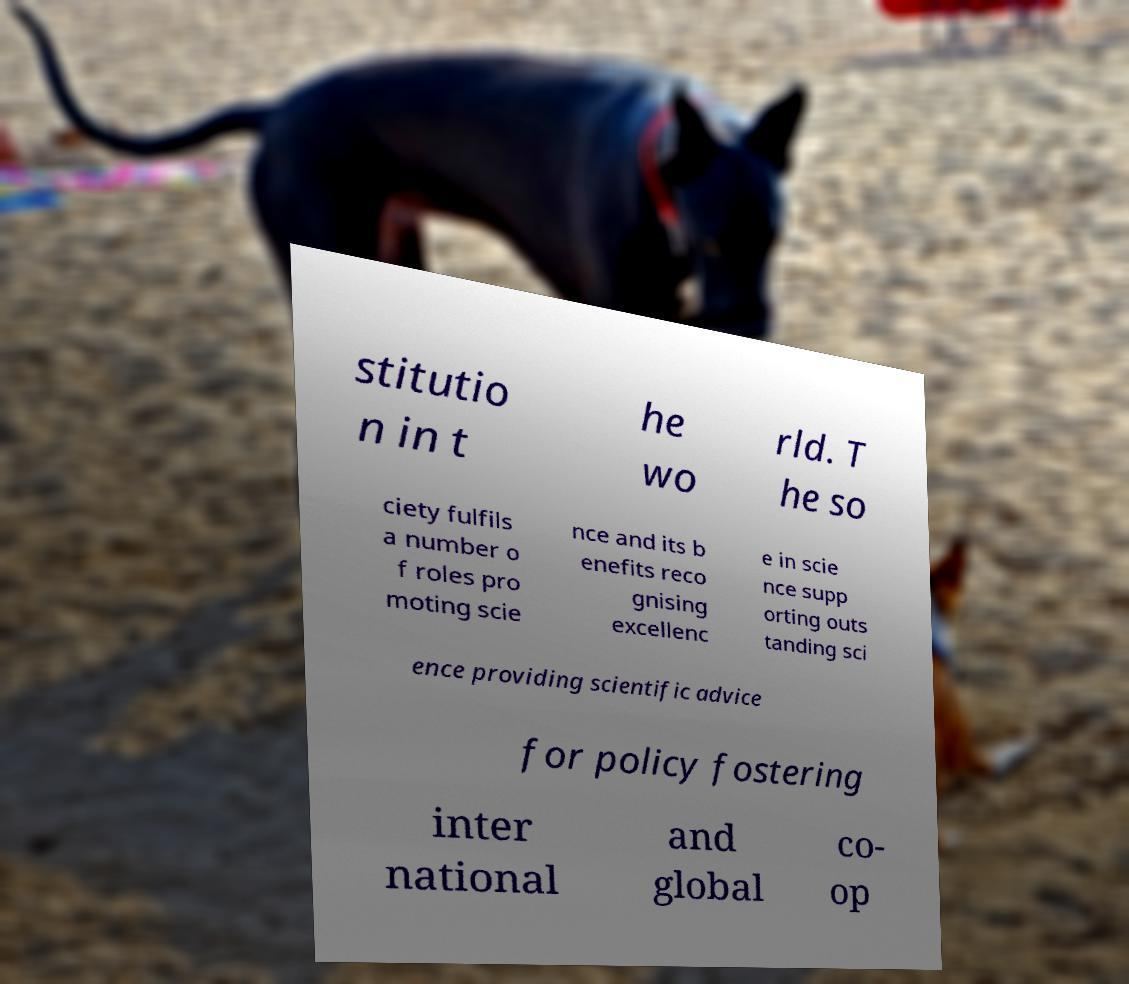There's text embedded in this image that I need extracted. Can you transcribe it verbatim? stitutio n in t he wo rld. T he so ciety fulfils a number o f roles pro moting scie nce and its b enefits reco gnising excellenc e in scie nce supp orting outs tanding sci ence providing scientific advice for policy fostering inter national and global co- op 